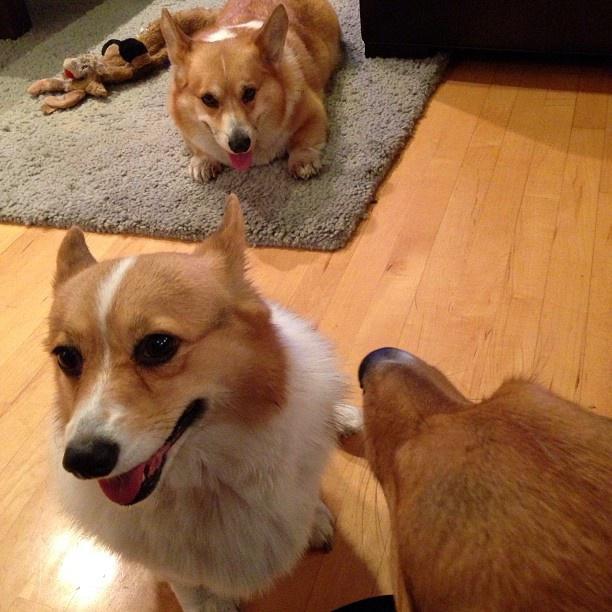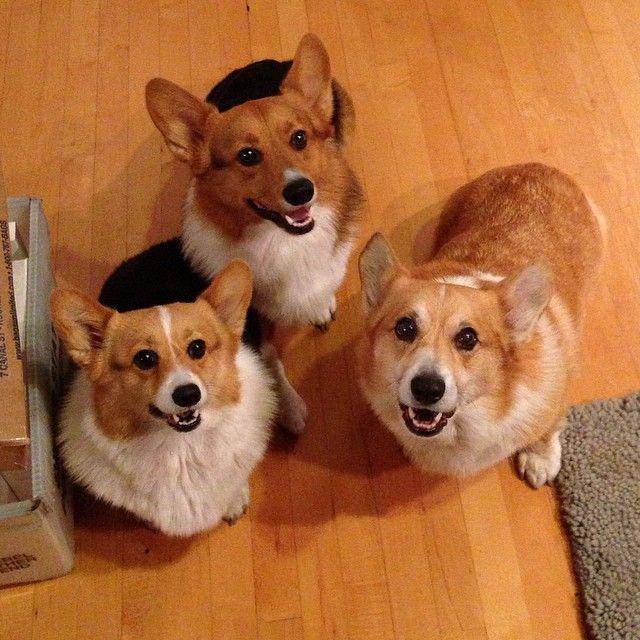The first image is the image on the left, the second image is the image on the right. Assess this claim about the two images: "There are no more than two dogs in the left image.". Correct or not? Answer yes or no. No. The first image is the image on the left, the second image is the image on the right. Analyze the images presented: Is the assertion "There are at most four dogs." valid? Answer yes or no. No. 